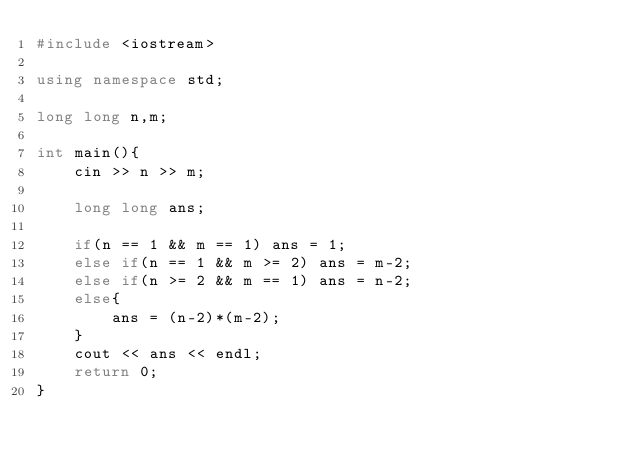<code> <loc_0><loc_0><loc_500><loc_500><_C++_>#include <iostream>

using namespace std;

long long n,m;

int main(){
    cin >> n >> m;

    long long ans;

    if(n == 1 && m == 1) ans = 1;
    else if(n == 1 && m >= 2) ans = m-2;
    else if(n >= 2 && m == 1) ans = n-2;
    else{
        ans = (n-2)*(m-2);
    }
    cout << ans << endl;
    return 0;
}
</code> 